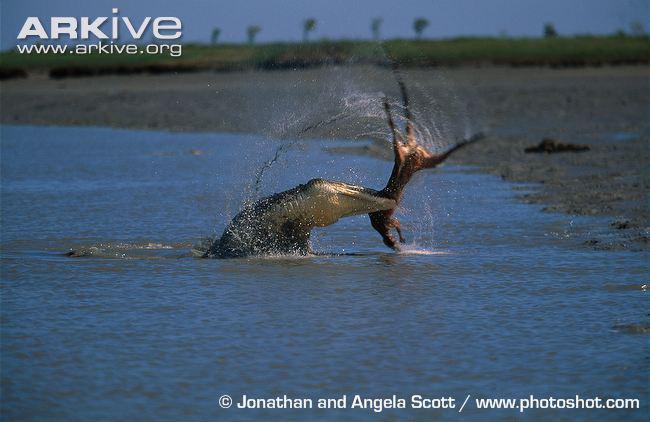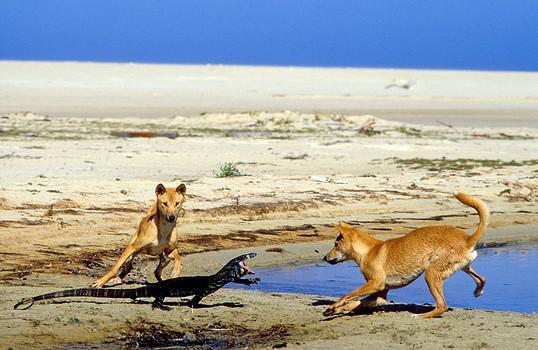The first image is the image on the left, the second image is the image on the right. Evaluate the accuracy of this statement regarding the images: "In each image there are a pair of dogs on a shore attacking a large lizard.". Is it true? Answer yes or no. No. 